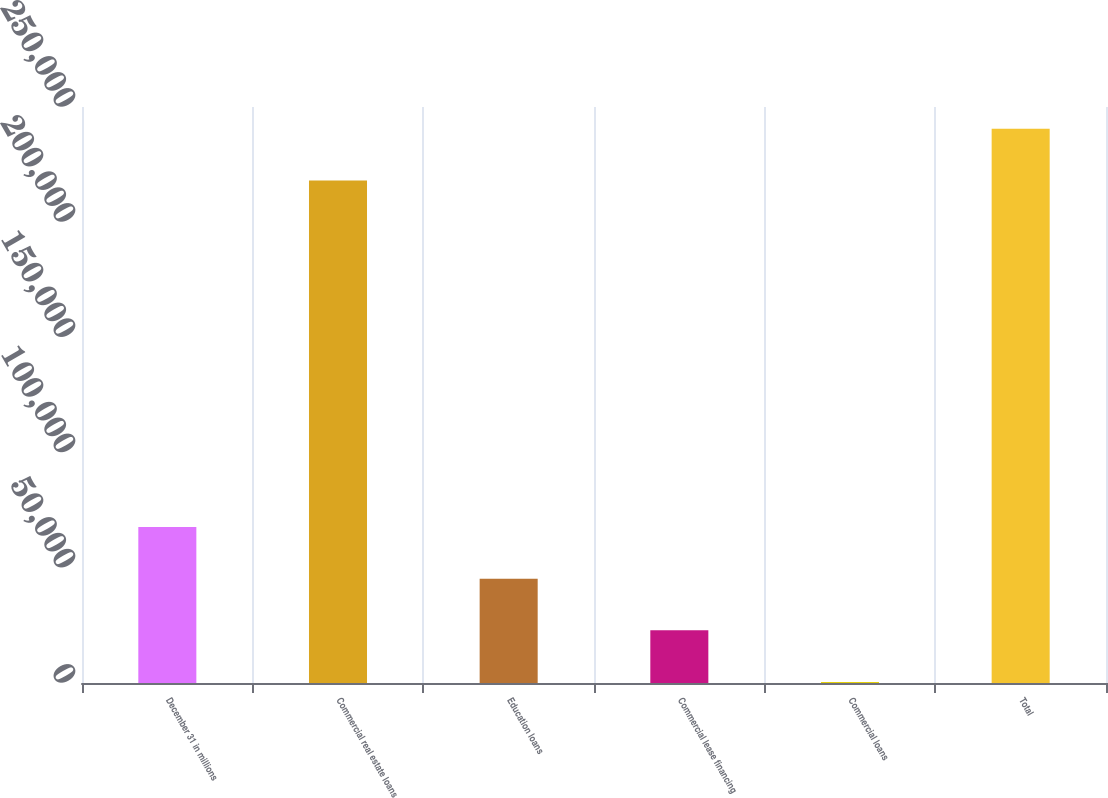Convert chart to OTSL. <chart><loc_0><loc_0><loc_500><loc_500><bar_chart><fcel>December 31 in millions<fcel>Commercial real estate loans<fcel>Education loans<fcel>Commercial lease financing<fcel>Commercial loans<fcel>Total<nl><fcel>67724.2<fcel>218135<fcel>45288.8<fcel>22853.4<fcel>418<fcel>240570<nl></chart> 